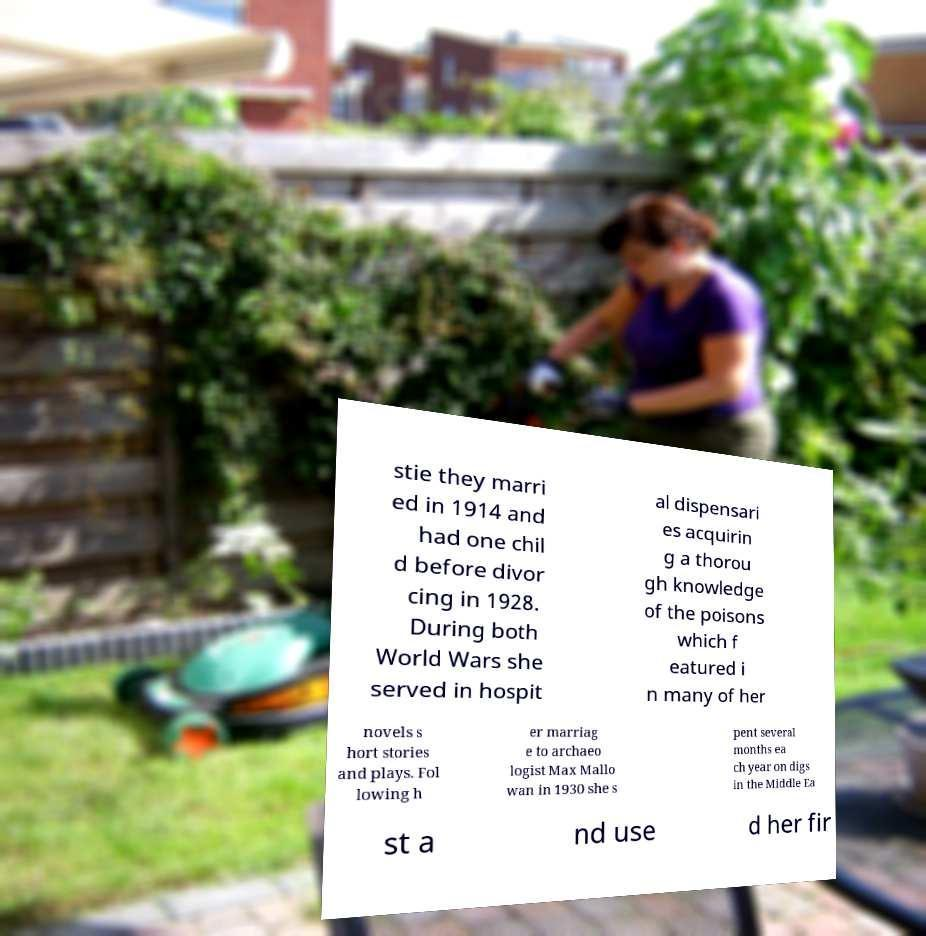For documentation purposes, I need the text within this image transcribed. Could you provide that? stie they marri ed in 1914 and had one chil d before divor cing in 1928. During both World Wars she served in hospit al dispensari es acquirin g a thorou gh knowledge of the poisons which f eatured i n many of her novels s hort stories and plays. Fol lowing h er marriag e to archaeo logist Max Mallo wan in 1930 she s pent several months ea ch year on digs in the Middle Ea st a nd use d her fir 